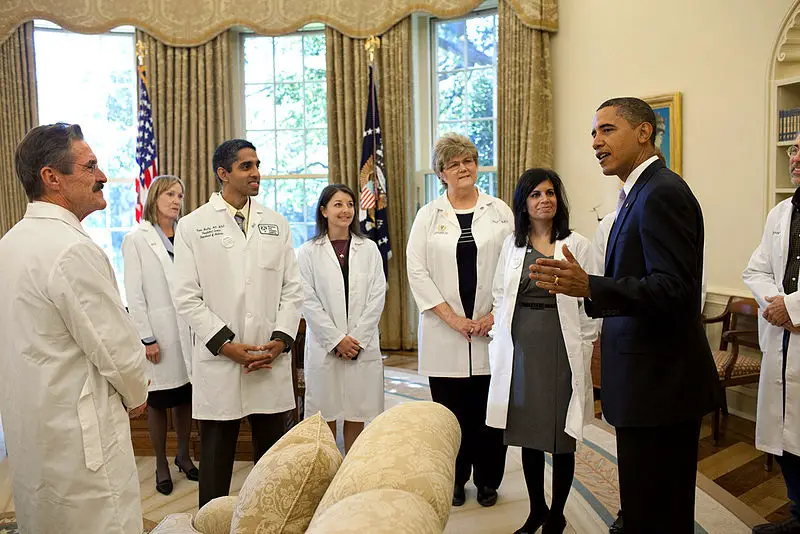If these individuals were characters in a fictional story set in a futuristic world, what roles could they play? In a futuristic world, these individuals could be part of an elite group of intergalactic health officers, working on a mission to prevent a pandemic that threatens multiple planets. The person in the suit might be the commander of a space-faring vessel, negotiating with medical experts who have developed advanced nanotechnology capable of curing diseases instantaneously. Their roles would involve strategizing on how to deploy these cures across vast distances, dealing with political entities from different planets, and ensuring that the technology is used ethically and effectively. Can you create a dialogue where they discuss their strategy to save an alien species from extinction? Commander: "Our scans show that the Trelvanians are rapidly succumbing to the viral outbreak. We need a plan to administer the antidote across their entire continent within the next 24 hours." 

Dr. Vortex (in white coat): "We've developed nanobots that can be released into their atmosphere. These bots will target the virus directly and neutralize it. We'll need to disperse them using high-altitude drones." 

Commander: "What are the risks to the Trelvanian ecosystem? We can't afford any unintended consequences." 

Dr. Aurora (another in white coat): "The nanobots are programmed to target only the virus and will self-deactivate after the mission is complete. Our simulations show minimal risk to non-target species." 

Commander: "Excellent. Dr. Zenith, coordinate with the drone pilots. We launch at dawn." 